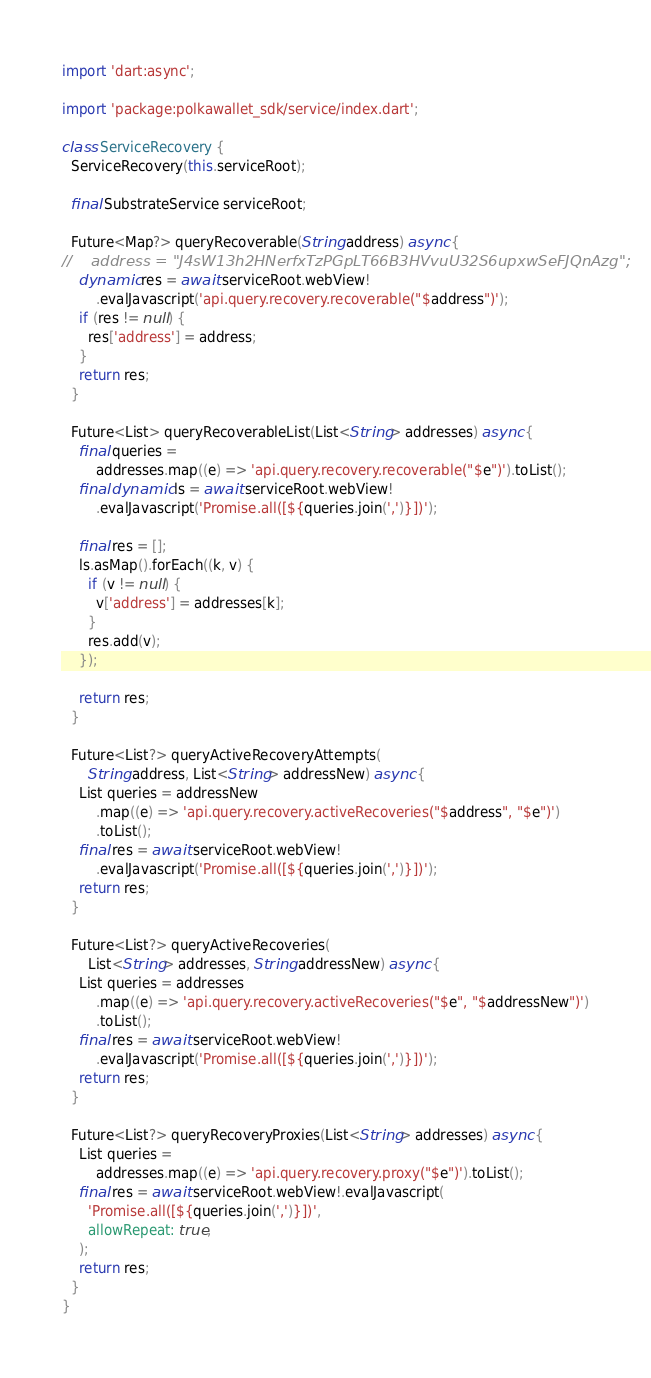<code> <loc_0><loc_0><loc_500><loc_500><_Dart_>import 'dart:async';

import 'package:polkawallet_sdk/service/index.dart';

class ServiceRecovery {
  ServiceRecovery(this.serviceRoot);

  final SubstrateService serviceRoot;

  Future<Map?> queryRecoverable(String address) async {
//    address = "J4sW13h2HNerfxTzPGpLT66B3HVvuU32S6upxwSeFJQnAzg";
    dynamic res = await serviceRoot.webView!
        .evalJavascript('api.query.recovery.recoverable("$address")');
    if (res != null) {
      res['address'] = address;
    }
    return res;
  }

  Future<List> queryRecoverableList(List<String> addresses) async {
    final queries =
        addresses.map((e) => 'api.query.recovery.recoverable("$e")').toList();
    final dynamic ls = await serviceRoot.webView!
        .evalJavascript('Promise.all([${queries.join(',')}])');

    final res = [];
    ls.asMap().forEach((k, v) {
      if (v != null) {
        v['address'] = addresses[k];
      }
      res.add(v);
    });

    return res;
  }

  Future<List?> queryActiveRecoveryAttempts(
      String address, List<String> addressNew) async {
    List queries = addressNew
        .map((e) => 'api.query.recovery.activeRecoveries("$address", "$e")')
        .toList();
    final res = await serviceRoot.webView!
        .evalJavascript('Promise.all([${queries.join(',')}])');
    return res;
  }

  Future<List?> queryActiveRecoveries(
      List<String> addresses, String addressNew) async {
    List queries = addresses
        .map((e) => 'api.query.recovery.activeRecoveries("$e", "$addressNew")')
        .toList();
    final res = await serviceRoot.webView!
        .evalJavascript('Promise.all([${queries.join(',')}])');
    return res;
  }

  Future<List?> queryRecoveryProxies(List<String> addresses) async {
    List queries =
        addresses.map((e) => 'api.query.recovery.proxy("$e")').toList();
    final res = await serviceRoot.webView!.evalJavascript(
      'Promise.all([${queries.join(',')}])',
      allowRepeat: true,
    );
    return res;
  }
}
</code> 